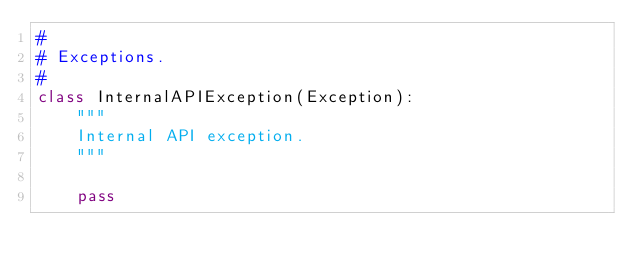Convert code to text. <code><loc_0><loc_0><loc_500><loc_500><_Python_>#
# Exceptions.
#
class InternalAPIException(Exception):
    """
    Internal API exception.
    """

    pass
</code> 